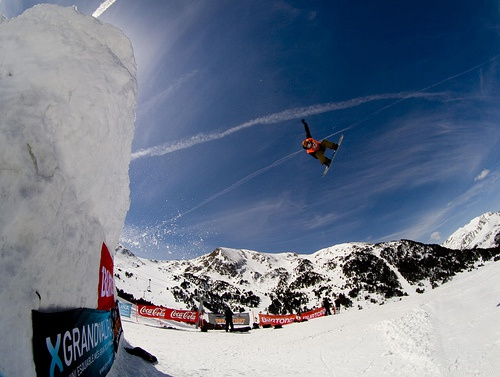Describe the objects in this image and their specific colors. I can see people in darkgray, black, navy, maroon, and brown tones, people in darkgray, black, lightgray, gray, and maroon tones, snowboard in darkgray, navy, gray, blue, and black tones, and people in darkgray, black, gray, purple, and lightgray tones in this image. 